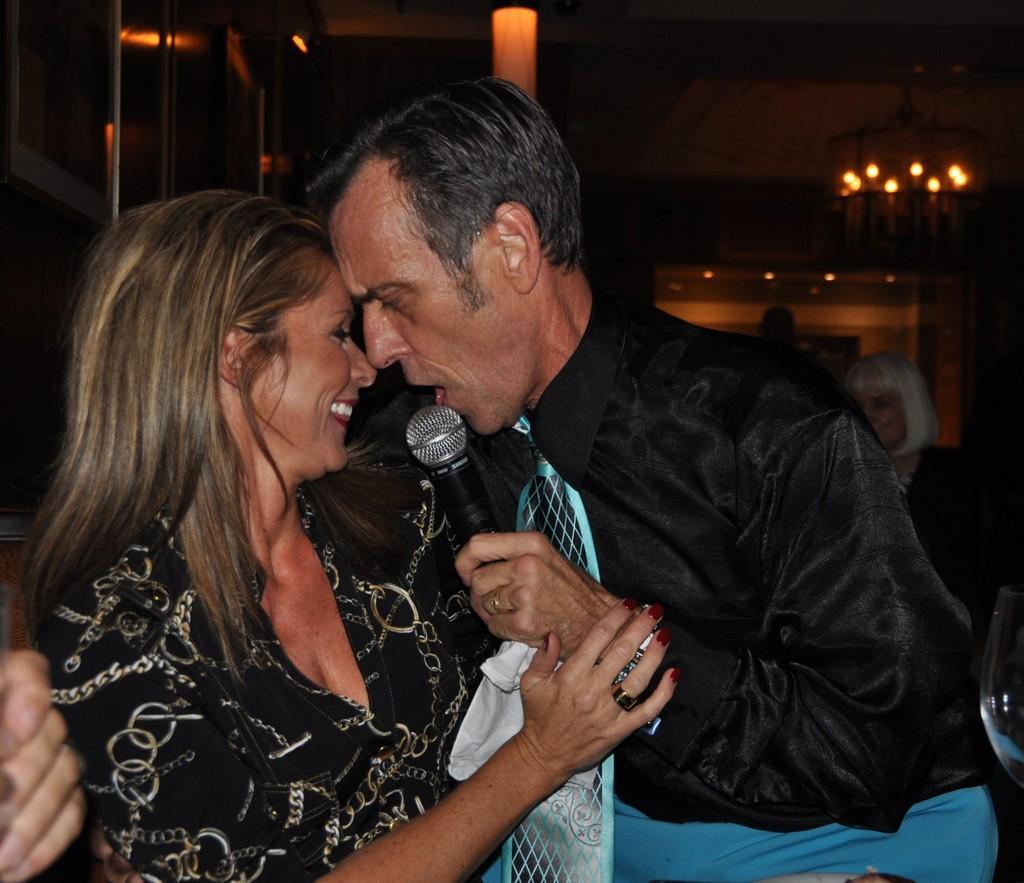In one or two sentences, can you explain what this image depicts? In this image I see a woman and a man and the man is holding a mic and there is a glass over here. In the background I can see a woman and few lights. 